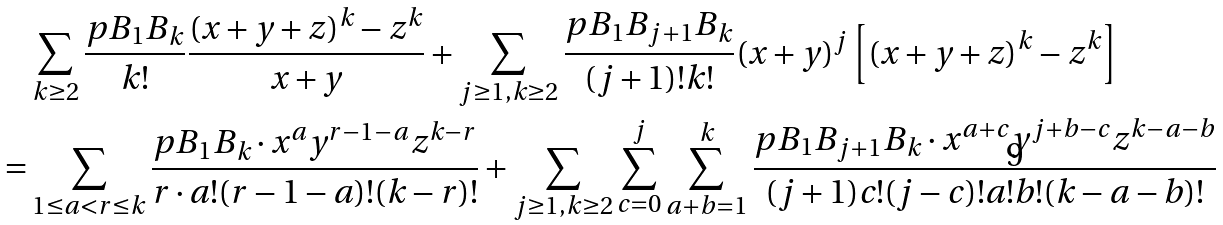<formula> <loc_0><loc_0><loc_500><loc_500>\ & \sum _ { k \geq 2 } \frac { p B _ { 1 } B _ { k } } { k ! } \frac { ( x + y + z ) ^ { k } - z ^ { k } } { x + y } + \sum _ { j \geq 1 , k \geq 2 } \frac { p B _ { 1 } B _ { j + 1 } B _ { k } } { ( j + 1 ) ! k ! } ( x + y ) ^ { j } \left [ ( x + y + z ) ^ { k } - z ^ { k } \right ] \\ = & \sum _ { 1 \leq a < r \leq k } \frac { p B _ { 1 } B _ { k } \cdot x ^ { a } y ^ { r - 1 - a } z ^ { k - r } } { r \cdot a ! ( r - 1 - a ) ! ( k - r ) ! } + \sum _ { j \geq 1 , k \geq 2 } \sum _ { c = 0 } ^ { j } \sum _ { a + b = 1 } ^ { k } \frac { p B _ { 1 } B _ { j + 1 } B _ { k } \cdot x ^ { a + c } y ^ { j + b - c } z ^ { k - a - b } } { ( j + 1 ) c ! ( j - c ) ! a ! b ! ( k - a - b ) ! }</formula> 